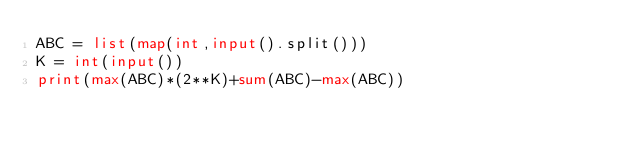Convert code to text. <code><loc_0><loc_0><loc_500><loc_500><_Python_>ABC = list(map(int,input().split()))
K = int(input())
print(max(ABC)*(2**K)+sum(ABC)-max(ABC))</code> 